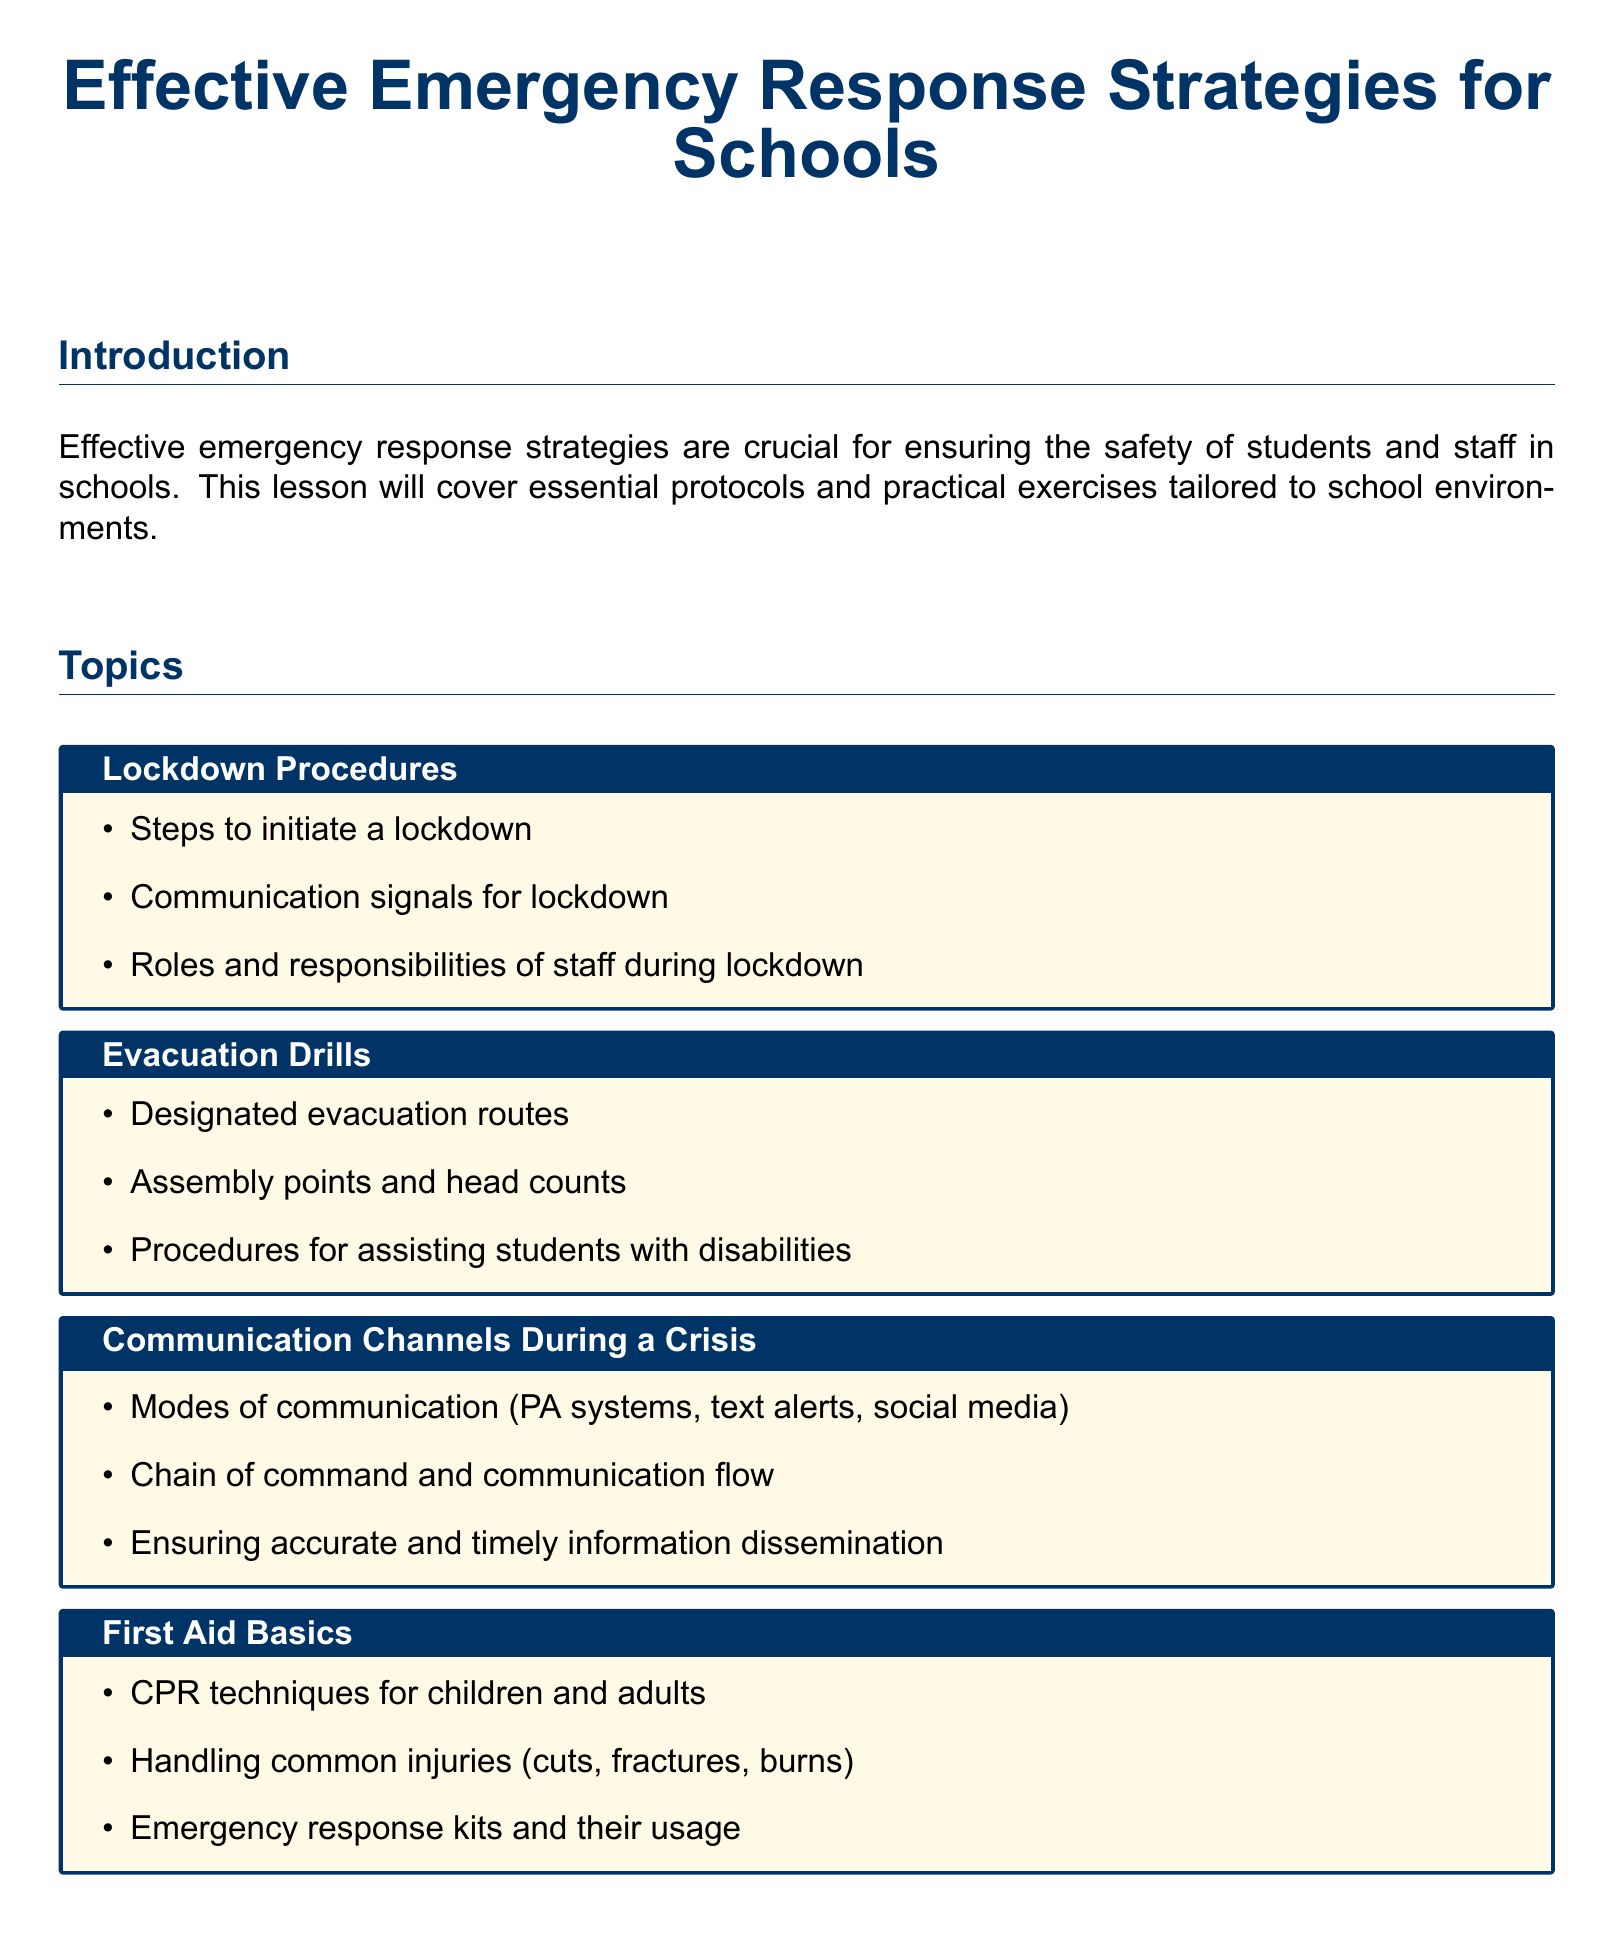What is the main focus of the lesson plan? The main focus of the lesson plan is on emergency response strategies for schools.
Answer: emergency response strategies for schools What is one topic covered under lockdown procedures? One of the topics covered is the steps to initiate a lockdown.
Answer: steps to initiate a lockdown How are students expected to demonstrate their understanding of the material? Students are expected to engage in scenario-based role-playing exercises to demonstrate their understanding.
Answer: scenario-based role-playing exercises What essential skill is included in the first aid basics? CPR techniques for children and adults is included as an essential skill in the first aid basics.
Answer: CPR techniques for children and adults Which aspect of school safety does the document emphasize through the communication topic? The communication topic emphasizes the chain of command and communication flow during a crisis.
Answer: chain of command and communication flow What is one component of the customized emergency response plan? One component is the assessment of school-specific risks.
Answer: assessment of school-specific risks Who is the lesson plan prepared by? The lesson plan is prepared by Jessica Smith, a Ph.D. student and public safety professional.
Answer: Jessica Smith What type of drills are mentioned in the evacuation section? The drills mentioned are evacuation drills.
Answer: evacuation drills 